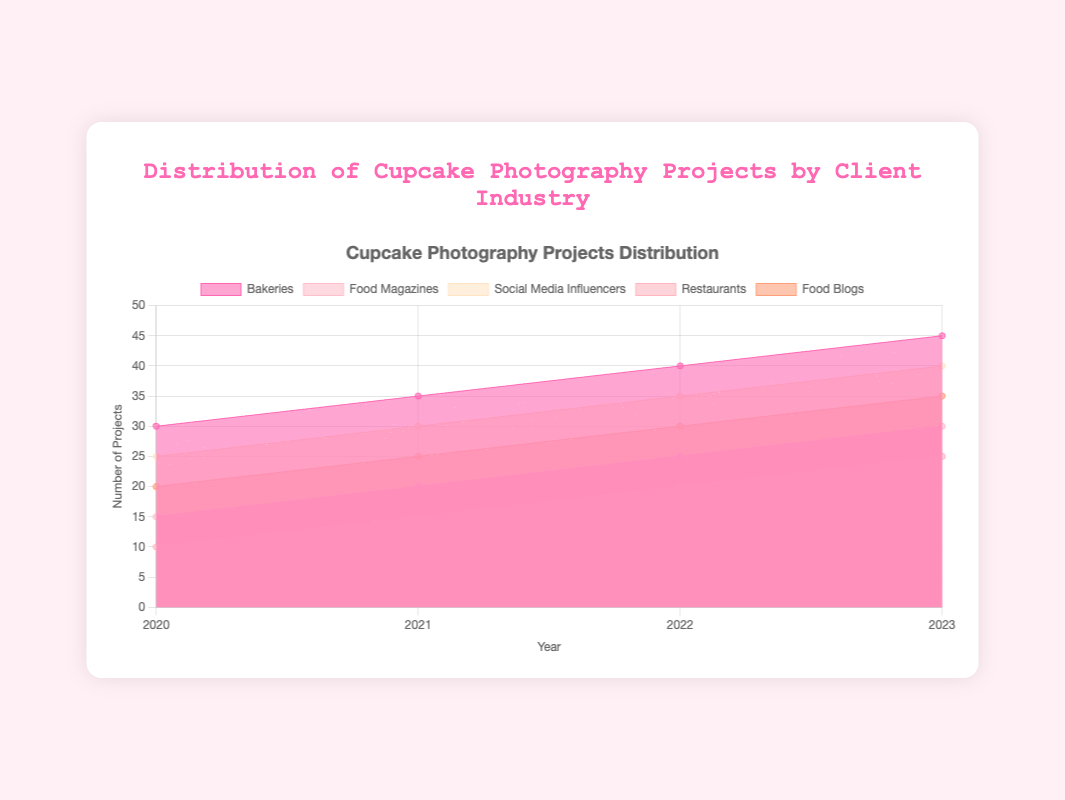What is the title of the chart? The title is displayed at the top of the chart and it reads, "Distribution of Cupcake Photography Projects by Client Industry".
Answer: Distribution of Cupcake Photography Projects by Client Industry How many client industries are represented in the chart? The chart has a legend that lists all the industries, which are Bakeries, Food Magazines, Social Media Influencers, Restaurants, and Food Blogs. There are 5 industries represented.
Answer: 5 Which client industry had the highest number of projects in 2021? Look at the data points for 2021 on the line chart and compare them. Bakeries are at the top with 35 projects.
Answer: Bakeries What is the total number of projects for Food Magazines over the years shown? Add the number of projects for Food Magazines for each year: 15 (2020) + 20 (2021) + 25 (2022) + 30 (2023). The total is 90.
Answer: 90 In which year did Restaurants have the fewest projects? Look at the Restaurant data line and find the lowest point, which is in 2020 with 10 projects.
Answer: 2020 Which client industry showed a consistent increase in projects every year? Check the line chart to see which lines are steadily increasing each year. All industries (Bakeries, Food Magazines, Social Media Influencers, Restaurants, and Food Blogs) showed a consistent increase.
Answer: All industries What is the average number of projects in 2023 for Social Media Influencers and Food Blogs combined? In 2023, Social Media Influencers had 40 projects and Food Blogs had 35 projects. The average is (40 + 35)/2 = 37.5.
Answer: 37.5 How much did the number of projects for Bakeries increase from 2020 to 2023? Subtract the number of projects in 2020 from the number in 2023 for Bakeries: 45 (2023) - 30 (2020) = 15.
Answer: 15 What is the difference in the number of projects between Food Magazines and Restaurants in 2022? Subtract the number of projects for Restaurants from Food Magazines in 2022: 25 (Food Magazines) - 20 (Restaurants) = 5.
Answer: 5 Which year saw the most significant growth in the number of projects for Social Media Influencers compared to the previous year? Calculate the year-over-year increase for Social Media Influencers: 2021-2020: 30-25=5 projects, 2022-2021: 35-30=5 projects, 2023-2022: 40-35=5 projects. All increases are the same, 5 projects per year.
Answer: All years saw same growth 